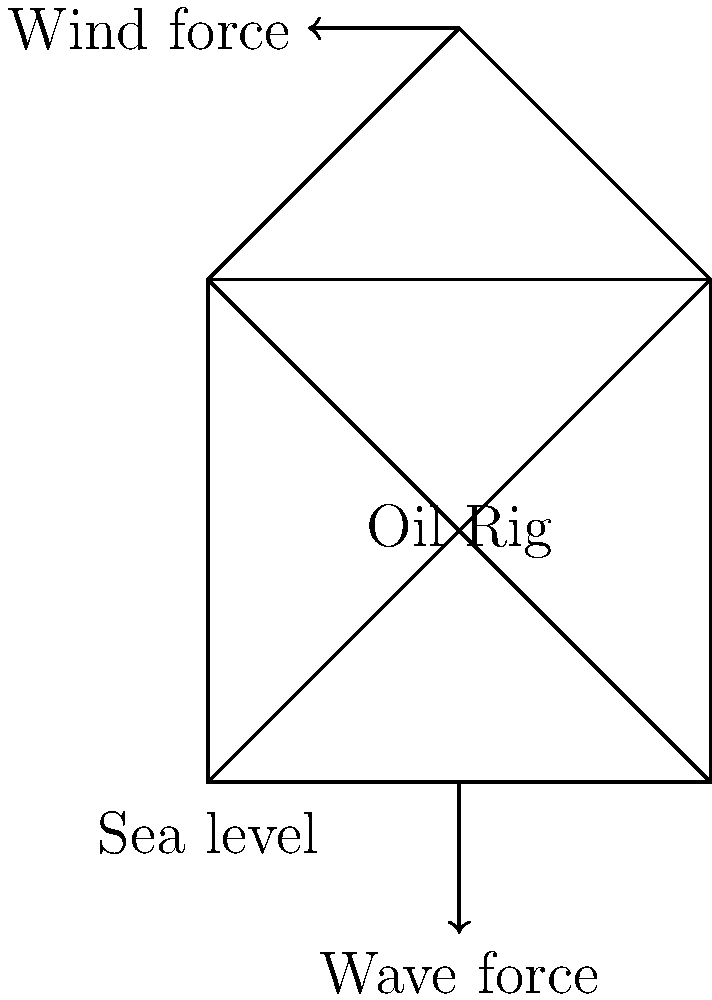During a severe storm, an offshore oil rig experiences both wind and wave forces. The wind force is estimated at 2.5 MN acting horizontally at the top of the structure, while the wave force is 3.8 MN acting horizontally at sea level. If the oil rig stands 150 meters tall, what is the magnitude of the resultant force acting on the structure, and at what height above sea level does it act? To solve this problem, we'll follow these steps:

1) First, we need to find the resultant force magnitude:
   - Wind force (F_w) = 2.5 MN
   - Wave force (F_v) = 3.8 MN
   - Both forces act in the same direction (horizontally)
   - Resultant force (F_R) = F_w + F_v = 2.5 MN + 3.8 MN = 6.3 MN

2) Now, we need to find the point of application of this resultant force. We can do this by taking moments about any point. Let's choose the base of the structure (sea level):

   - Moment due to wind force = 2.5 MN × 150 m = 375 MN·m
   - Moment due to wave force = 3.8 MN × 0 m = 0 MN·m
   - Total moment = 375 MN·m

3) The resultant force (6.3 MN) acting at height h should produce the same moment:

   6.3 MN × h = 375 MN·m

4) Solve for h:
   h = 375 MN·m ÷ 6.3 MN = 59.52 m

Therefore, the resultant force of 6.3 MN acts at a height of approximately 59.52 meters above sea level.
Answer: 6.3 MN acting at 59.52 m above sea level 